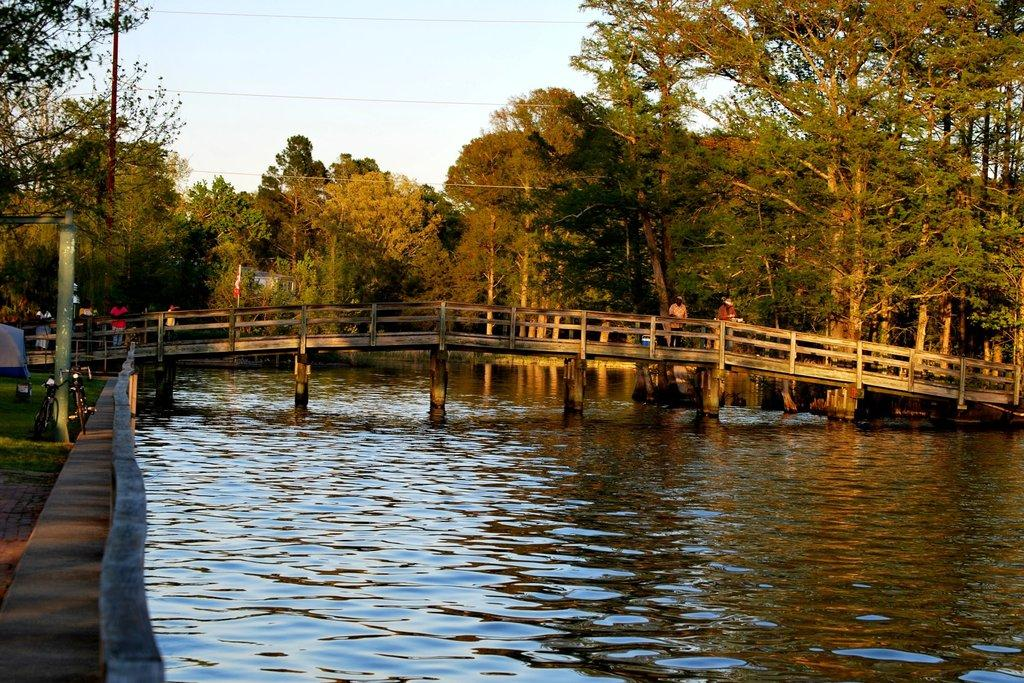What is at the bottom of the image? There is water at the bottom of the image. What structure can be seen in the middle of the image? There is a bridge in the middle of the image. What are the people in the image doing? The people are standing on the bridge. What type of vegetation is visible in the background of the image? There are trees in the background of the image. What is visible at the top of the image? The sky is visible at the top of the image. What type of print can be seen on the daughter's shirt in the image? There is no daughter present in the image, and therefore no shirt or print to observe. 